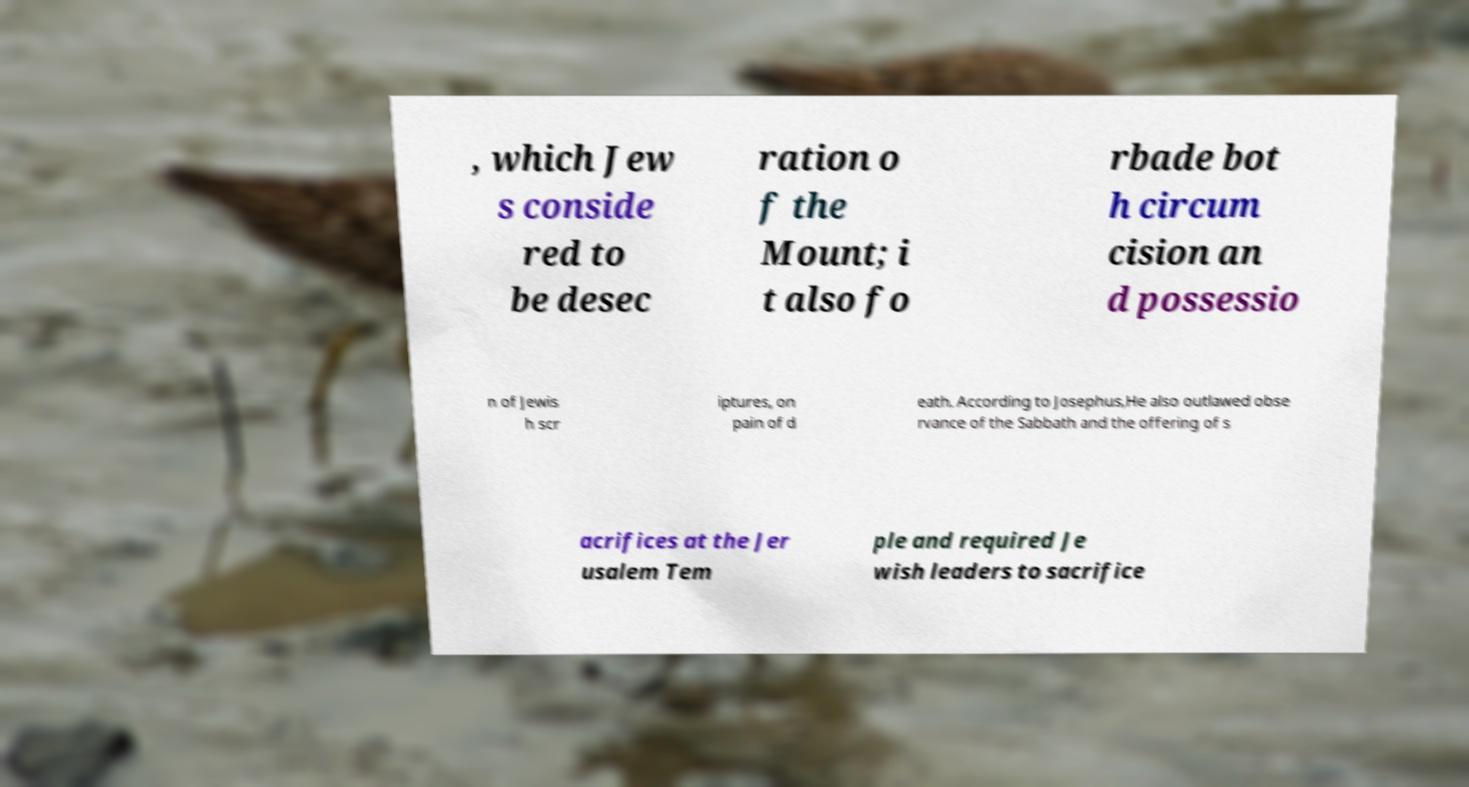Please read and relay the text visible in this image. What does it say? , which Jew s conside red to be desec ration o f the Mount; i t also fo rbade bot h circum cision an d possessio n of Jewis h scr iptures, on pain of d eath. According to Josephus,He also outlawed obse rvance of the Sabbath and the offering of s acrifices at the Jer usalem Tem ple and required Je wish leaders to sacrifice 